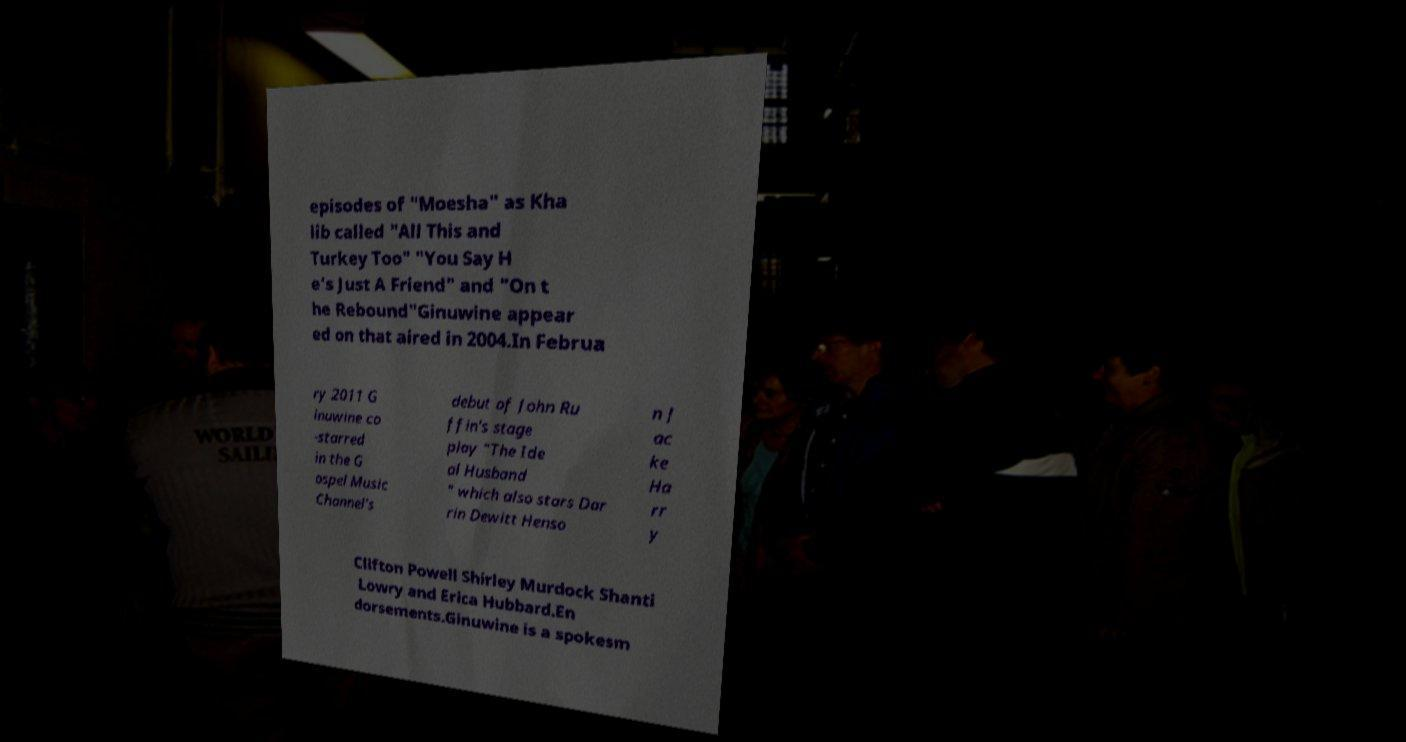Could you assist in decoding the text presented in this image and type it out clearly? episodes of "Moesha" as Kha lib called "All This and Turkey Too" "You Say H e's Just A Friend" and "On t he Rebound"Ginuwine appear ed on that aired in 2004.In Februa ry 2011 G inuwine co -starred in the G ospel Music Channel's debut of John Ru ffin's stage play "The Ide al Husband " which also stars Dar rin Dewitt Henso n J ac ke Ha rr y Clifton Powell Shirley Murdock Shanti Lowry and Erica Hubbard.En dorsements.Ginuwine is a spokesm 